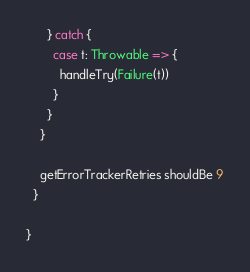Convert code to text. <code><loc_0><loc_0><loc_500><loc_500><_Scala_>      } catch {
        case t: Throwable => {
          handleTry(Failure(t))
        }
      }
    }

    getErrorTrackerRetries shouldBe 9
  }

}
</code> 